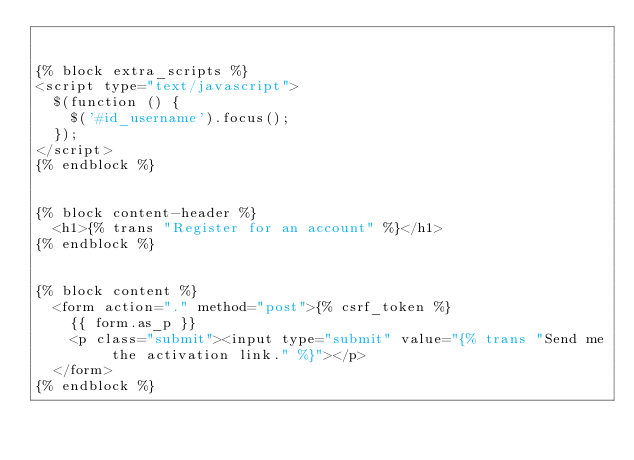Convert code to text. <code><loc_0><loc_0><loc_500><loc_500><_HTML_>

{% block extra_scripts %}
<script type="text/javascript">
  $(function () {
    $('#id_username').focus();
  });
</script>
{% endblock %}


{% block content-header %}
  <h1>{% trans "Register for an account" %}</h1>
{% endblock %}


{% block content %}
  <form action="." method="post">{% csrf_token %}
    {{ form.as_p }}
    <p class="submit"><input type="submit" value="{% trans "Send me the activation link." %}"></p>
  </form>
{% endblock %}
</code> 